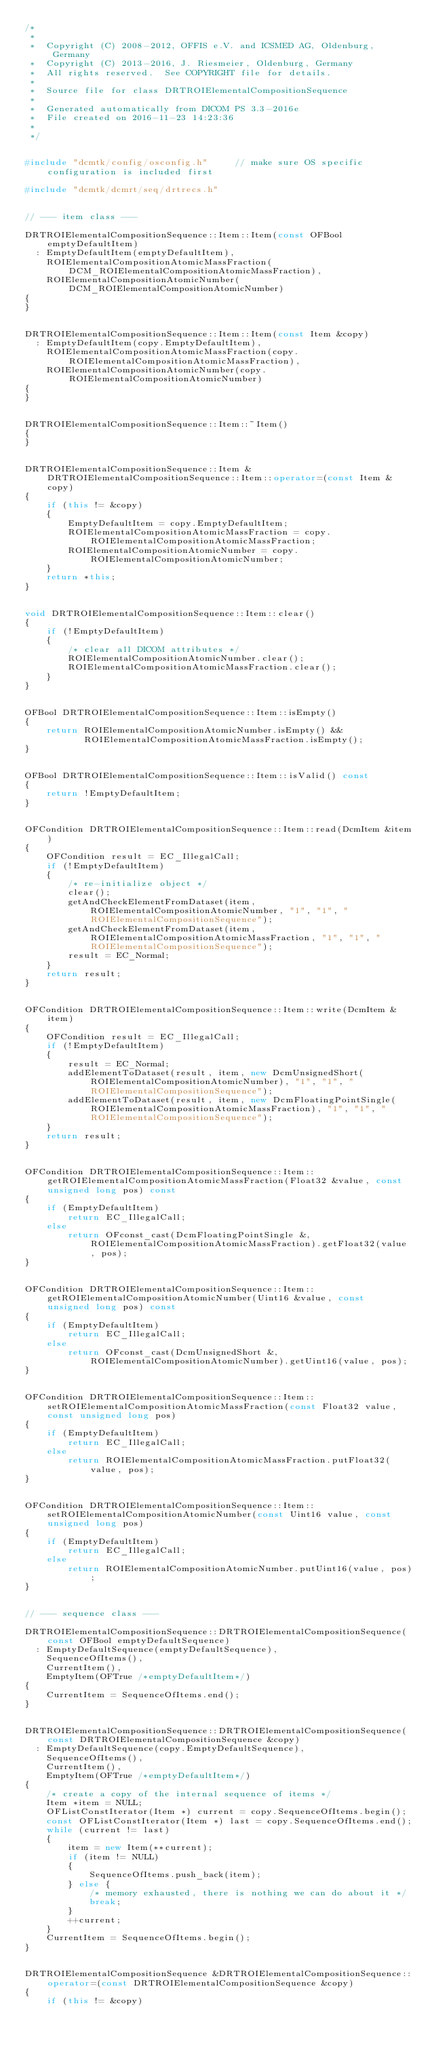<code> <loc_0><loc_0><loc_500><loc_500><_C++_>/*
 *
 *  Copyright (C) 2008-2012, OFFIS e.V. and ICSMED AG, Oldenburg, Germany
 *  Copyright (C) 2013-2016, J. Riesmeier, Oldenburg, Germany
 *  All rights reserved.  See COPYRIGHT file for details.
 *
 *  Source file for class DRTROIElementalCompositionSequence
 *
 *  Generated automatically from DICOM PS 3.3-2016e
 *  File created on 2016-11-23 14:23:36
 *
 */


#include "dcmtk/config/osconfig.h"     // make sure OS specific configuration is included first

#include "dcmtk/dcmrt/seq/drtrecs.h"


// --- item class ---

DRTROIElementalCompositionSequence::Item::Item(const OFBool emptyDefaultItem)
  : EmptyDefaultItem(emptyDefaultItem),
    ROIElementalCompositionAtomicMassFraction(DCM_ROIElementalCompositionAtomicMassFraction),
    ROIElementalCompositionAtomicNumber(DCM_ROIElementalCompositionAtomicNumber)
{
}


DRTROIElementalCompositionSequence::Item::Item(const Item &copy)
  : EmptyDefaultItem(copy.EmptyDefaultItem),
    ROIElementalCompositionAtomicMassFraction(copy.ROIElementalCompositionAtomicMassFraction),
    ROIElementalCompositionAtomicNumber(copy.ROIElementalCompositionAtomicNumber)
{
}


DRTROIElementalCompositionSequence::Item::~Item()
{
}


DRTROIElementalCompositionSequence::Item &DRTROIElementalCompositionSequence::Item::operator=(const Item &copy)
{
    if (this != &copy)
    {
        EmptyDefaultItem = copy.EmptyDefaultItem;
        ROIElementalCompositionAtomicMassFraction = copy.ROIElementalCompositionAtomicMassFraction;
        ROIElementalCompositionAtomicNumber = copy.ROIElementalCompositionAtomicNumber;
    }
    return *this;
}


void DRTROIElementalCompositionSequence::Item::clear()
{
    if (!EmptyDefaultItem)
    {
        /* clear all DICOM attributes */
        ROIElementalCompositionAtomicNumber.clear();
        ROIElementalCompositionAtomicMassFraction.clear();
    }
}


OFBool DRTROIElementalCompositionSequence::Item::isEmpty()
{
    return ROIElementalCompositionAtomicNumber.isEmpty() &&
           ROIElementalCompositionAtomicMassFraction.isEmpty();
}


OFBool DRTROIElementalCompositionSequence::Item::isValid() const
{
    return !EmptyDefaultItem;
}


OFCondition DRTROIElementalCompositionSequence::Item::read(DcmItem &item)
{
    OFCondition result = EC_IllegalCall;
    if (!EmptyDefaultItem)
    {
        /* re-initialize object */
        clear();
        getAndCheckElementFromDataset(item, ROIElementalCompositionAtomicNumber, "1", "1", "ROIElementalCompositionSequence");
        getAndCheckElementFromDataset(item, ROIElementalCompositionAtomicMassFraction, "1", "1", "ROIElementalCompositionSequence");
        result = EC_Normal;
    }
    return result;
}


OFCondition DRTROIElementalCompositionSequence::Item::write(DcmItem &item)
{
    OFCondition result = EC_IllegalCall;
    if (!EmptyDefaultItem)
    {
        result = EC_Normal;
        addElementToDataset(result, item, new DcmUnsignedShort(ROIElementalCompositionAtomicNumber), "1", "1", "ROIElementalCompositionSequence");
        addElementToDataset(result, item, new DcmFloatingPointSingle(ROIElementalCompositionAtomicMassFraction), "1", "1", "ROIElementalCompositionSequence");
    }
    return result;
}


OFCondition DRTROIElementalCompositionSequence::Item::getROIElementalCompositionAtomicMassFraction(Float32 &value, const unsigned long pos) const
{
    if (EmptyDefaultItem)
        return EC_IllegalCall;
    else
        return OFconst_cast(DcmFloatingPointSingle &, ROIElementalCompositionAtomicMassFraction).getFloat32(value, pos);
}


OFCondition DRTROIElementalCompositionSequence::Item::getROIElementalCompositionAtomicNumber(Uint16 &value, const unsigned long pos) const
{
    if (EmptyDefaultItem)
        return EC_IllegalCall;
    else
        return OFconst_cast(DcmUnsignedShort &, ROIElementalCompositionAtomicNumber).getUint16(value, pos);
}


OFCondition DRTROIElementalCompositionSequence::Item::setROIElementalCompositionAtomicMassFraction(const Float32 value, const unsigned long pos)
{
    if (EmptyDefaultItem)
        return EC_IllegalCall;
    else
        return ROIElementalCompositionAtomicMassFraction.putFloat32(value, pos);
}


OFCondition DRTROIElementalCompositionSequence::Item::setROIElementalCompositionAtomicNumber(const Uint16 value, const unsigned long pos)
{
    if (EmptyDefaultItem)
        return EC_IllegalCall;
    else
        return ROIElementalCompositionAtomicNumber.putUint16(value, pos);
}


// --- sequence class ---

DRTROIElementalCompositionSequence::DRTROIElementalCompositionSequence(const OFBool emptyDefaultSequence)
  : EmptyDefaultSequence(emptyDefaultSequence),
    SequenceOfItems(),
    CurrentItem(),
    EmptyItem(OFTrue /*emptyDefaultItem*/)
{
    CurrentItem = SequenceOfItems.end();
}


DRTROIElementalCompositionSequence::DRTROIElementalCompositionSequence(const DRTROIElementalCompositionSequence &copy)
  : EmptyDefaultSequence(copy.EmptyDefaultSequence),
    SequenceOfItems(),
    CurrentItem(),
    EmptyItem(OFTrue /*emptyDefaultItem*/)
{
    /* create a copy of the internal sequence of items */
    Item *item = NULL;
    OFListConstIterator(Item *) current = copy.SequenceOfItems.begin();
    const OFListConstIterator(Item *) last = copy.SequenceOfItems.end();
    while (current != last)
    {
        item = new Item(**current);
        if (item != NULL)
        {
            SequenceOfItems.push_back(item);
        } else {
            /* memory exhausted, there is nothing we can do about it */
            break;
        }
        ++current;
    }
    CurrentItem = SequenceOfItems.begin();
}


DRTROIElementalCompositionSequence &DRTROIElementalCompositionSequence::operator=(const DRTROIElementalCompositionSequence &copy)
{
    if (this != &copy)</code> 